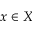<formula> <loc_0><loc_0><loc_500><loc_500>x \in X</formula> 